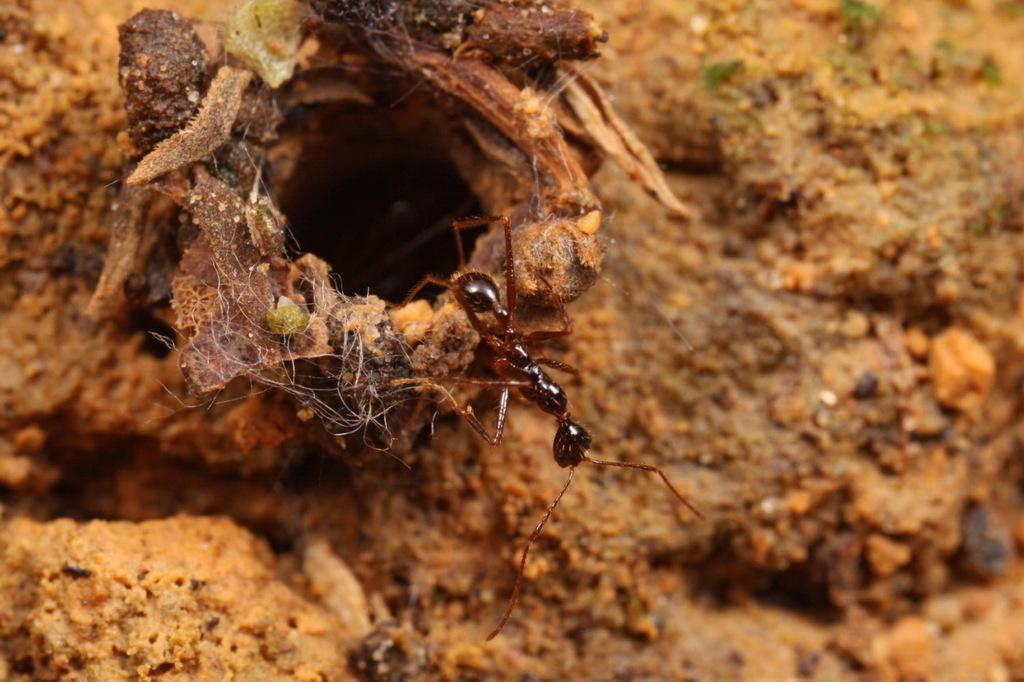Please provide a concise description of this image. In this image there is ant coming out from the ant colony. In the background there is a soil land. 